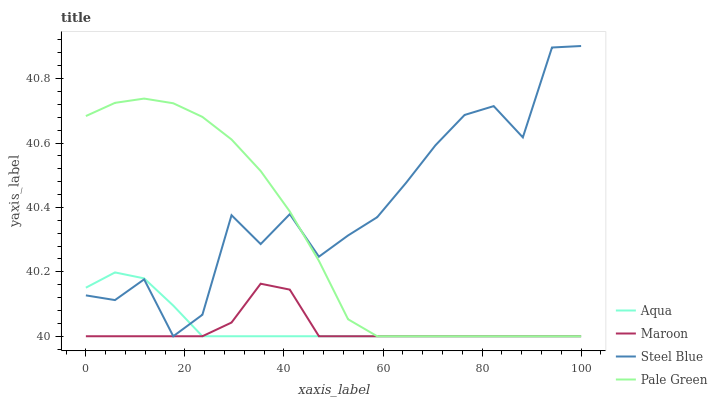Does Maroon have the minimum area under the curve?
Answer yes or no. Yes. Does Steel Blue have the maximum area under the curve?
Answer yes or no. Yes. Does Aqua have the minimum area under the curve?
Answer yes or no. No. Does Aqua have the maximum area under the curve?
Answer yes or no. No. Is Aqua the smoothest?
Answer yes or no. Yes. Is Steel Blue the roughest?
Answer yes or no. Yes. Is Steel Blue the smoothest?
Answer yes or no. No. Is Aqua the roughest?
Answer yes or no. No. Does Aqua have the highest value?
Answer yes or no. No. 